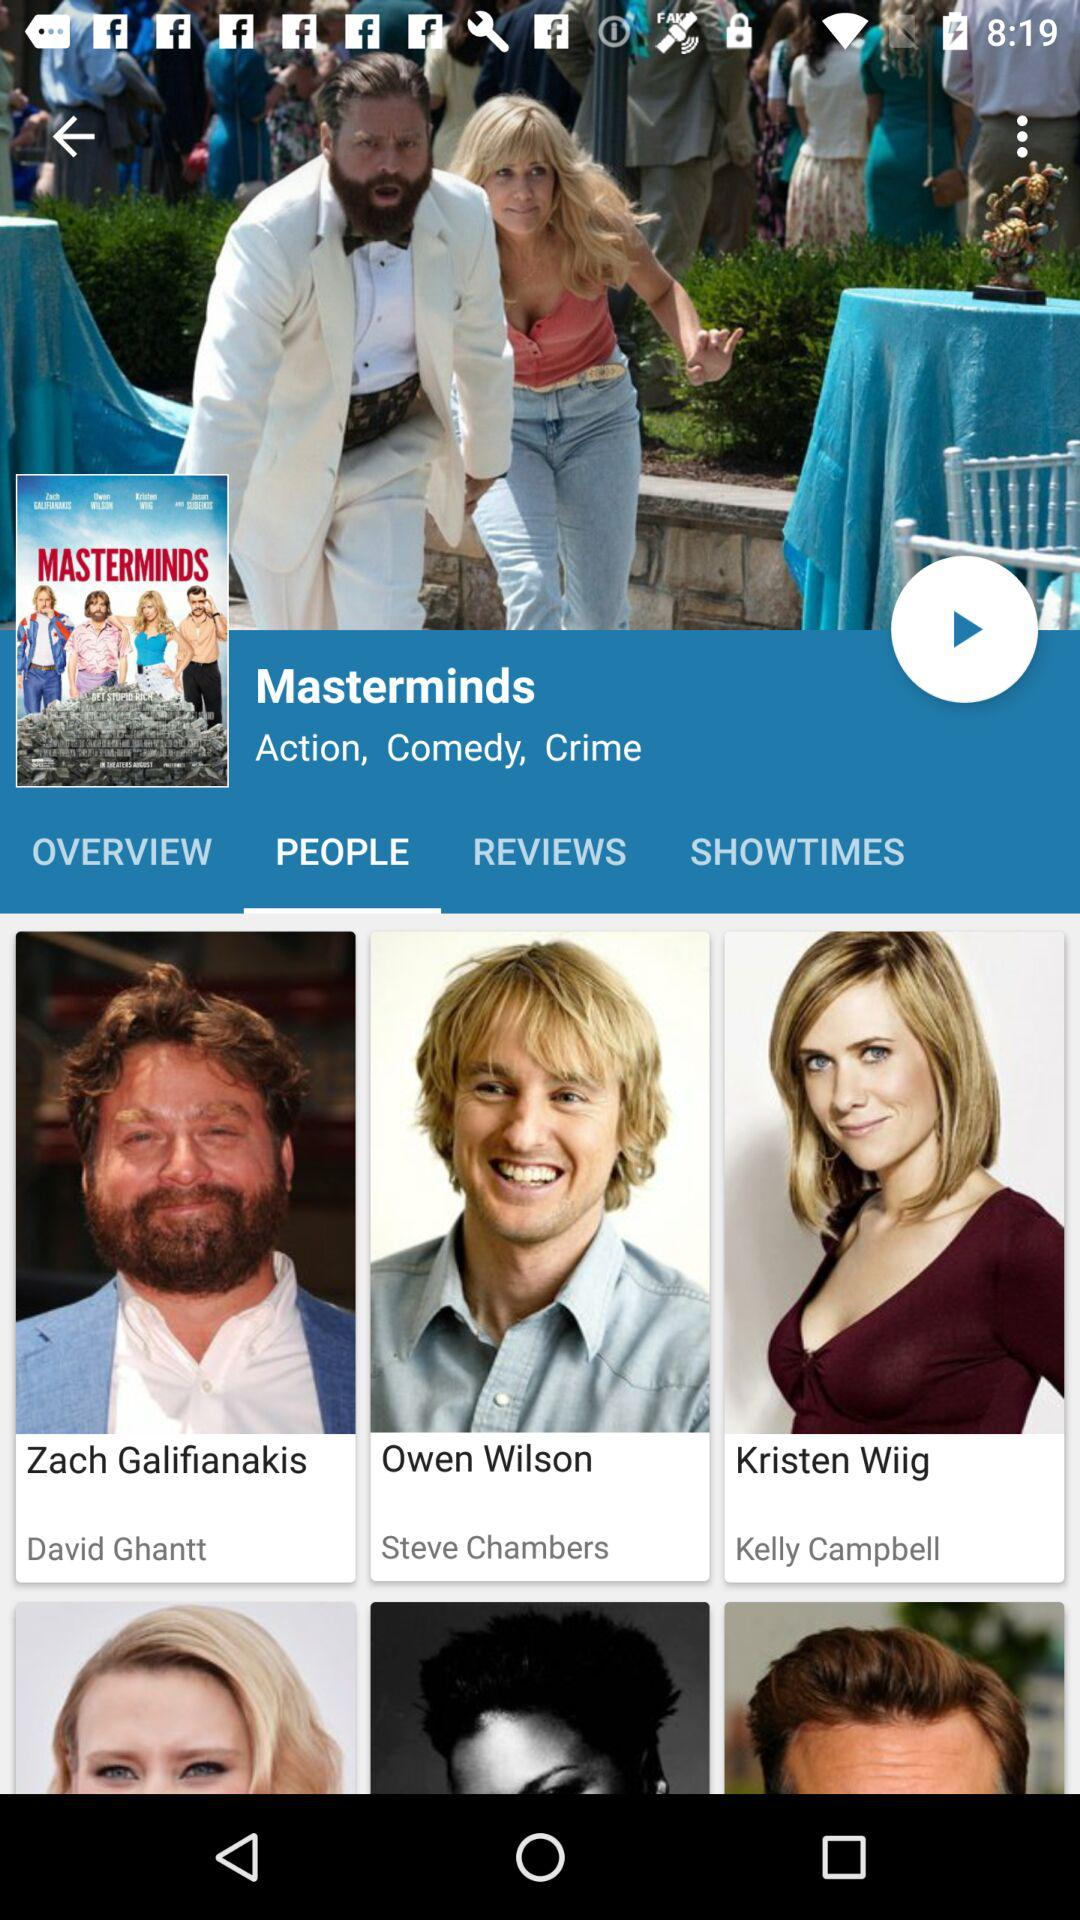How many more actors are in the movie's cast than actresses?
Answer the question using a single word or phrase. 1 